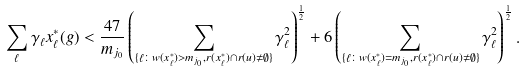<formula> <loc_0><loc_0><loc_500><loc_500>& \sum _ { \ell } \gamma _ { \ell } x ^ { * } _ { \ell } ( g ) < \frac { 4 7 } { m _ { j _ { 0 } } } \left ( \sum _ { \{ \ell \colon w ( x _ { \ell } ^ { * } ) > m _ { j _ { 0 } } , r ( x ^ { * } _ { \ell } ) \cap r ( u ) \not = \emptyset \} } \gamma _ { \ell } ^ { 2 } \right ) ^ { \frac { 1 } { 2 } } + 6 \left ( \sum _ { \{ \ell \colon w ( x _ { \ell } ^ { * } ) = m _ { j _ { 0 } } , r ( x ^ { * } _ { \ell } ) \cap r ( u ) \not = \emptyset \} } \gamma _ { \ell } ^ { 2 } \right ) ^ { \frac { 1 } { 2 } } .</formula> 